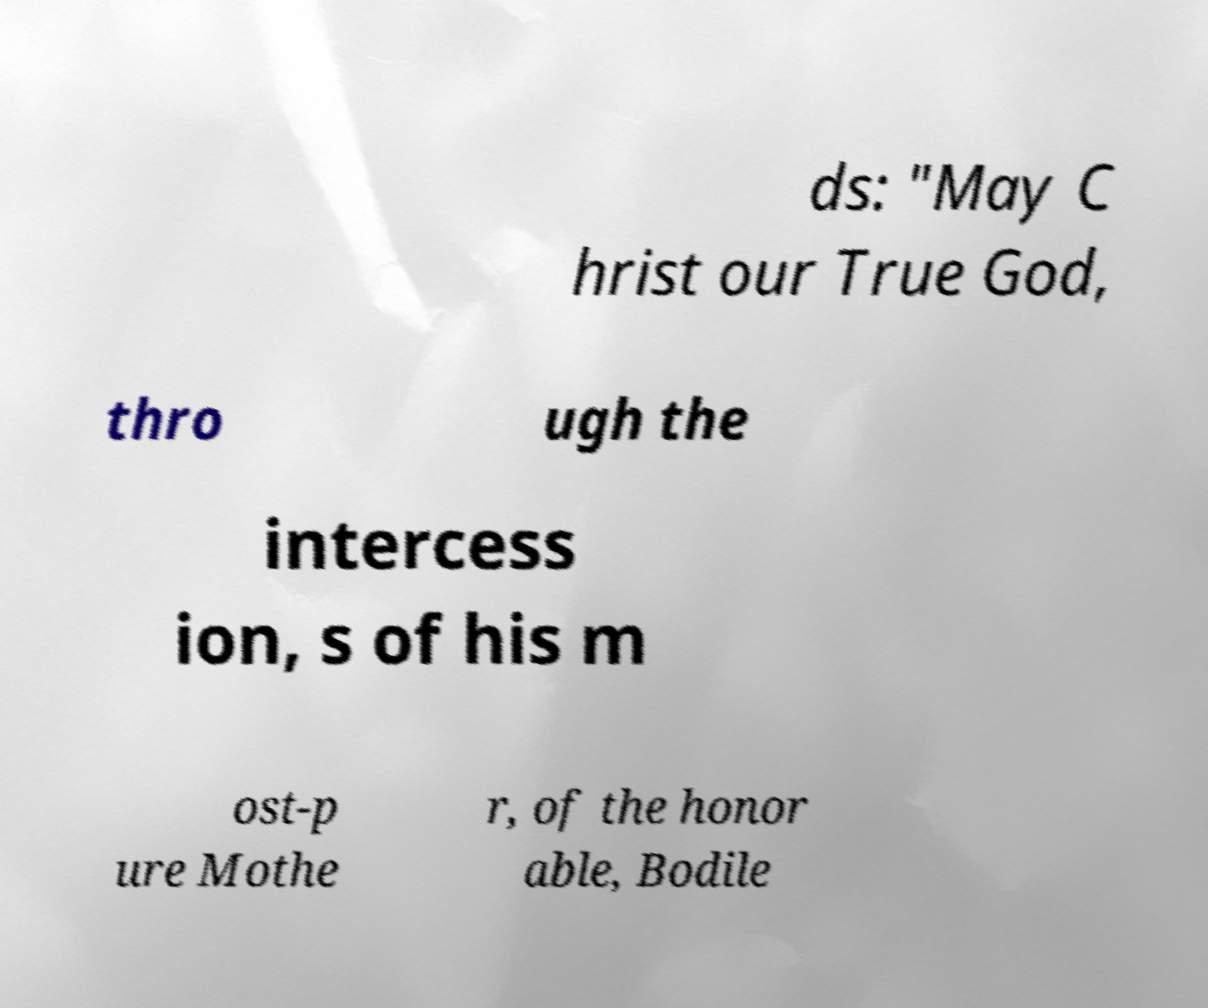Could you extract and type out the text from this image? ds: "May C hrist our True God, thro ugh the intercess ion, s of his m ost-p ure Mothe r, of the honor able, Bodile 